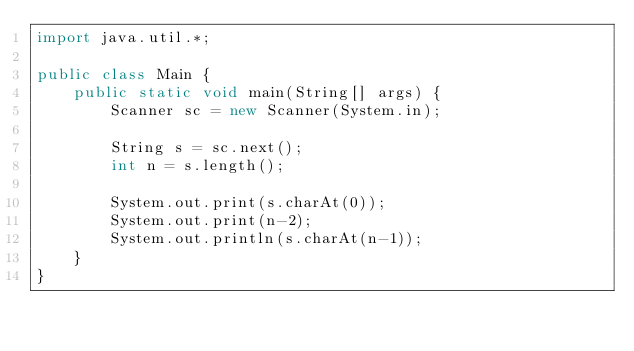<code> <loc_0><loc_0><loc_500><loc_500><_Java_>import java.util.*;

public class Main {
    public static void main(String[] args) {
        Scanner sc = new Scanner(System.in);

        String s = sc.next();
        int n = s.length();

        System.out.print(s.charAt(0));
        System.out.print(n-2);
        System.out.println(s.charAt(n-1));
    }
}

</code> 